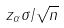Convert formula to latex. <formula><loc_0><loc_0><loc_500><loc_500>z _ { \alpha } \sigma / \sqrt { n }</formula> 